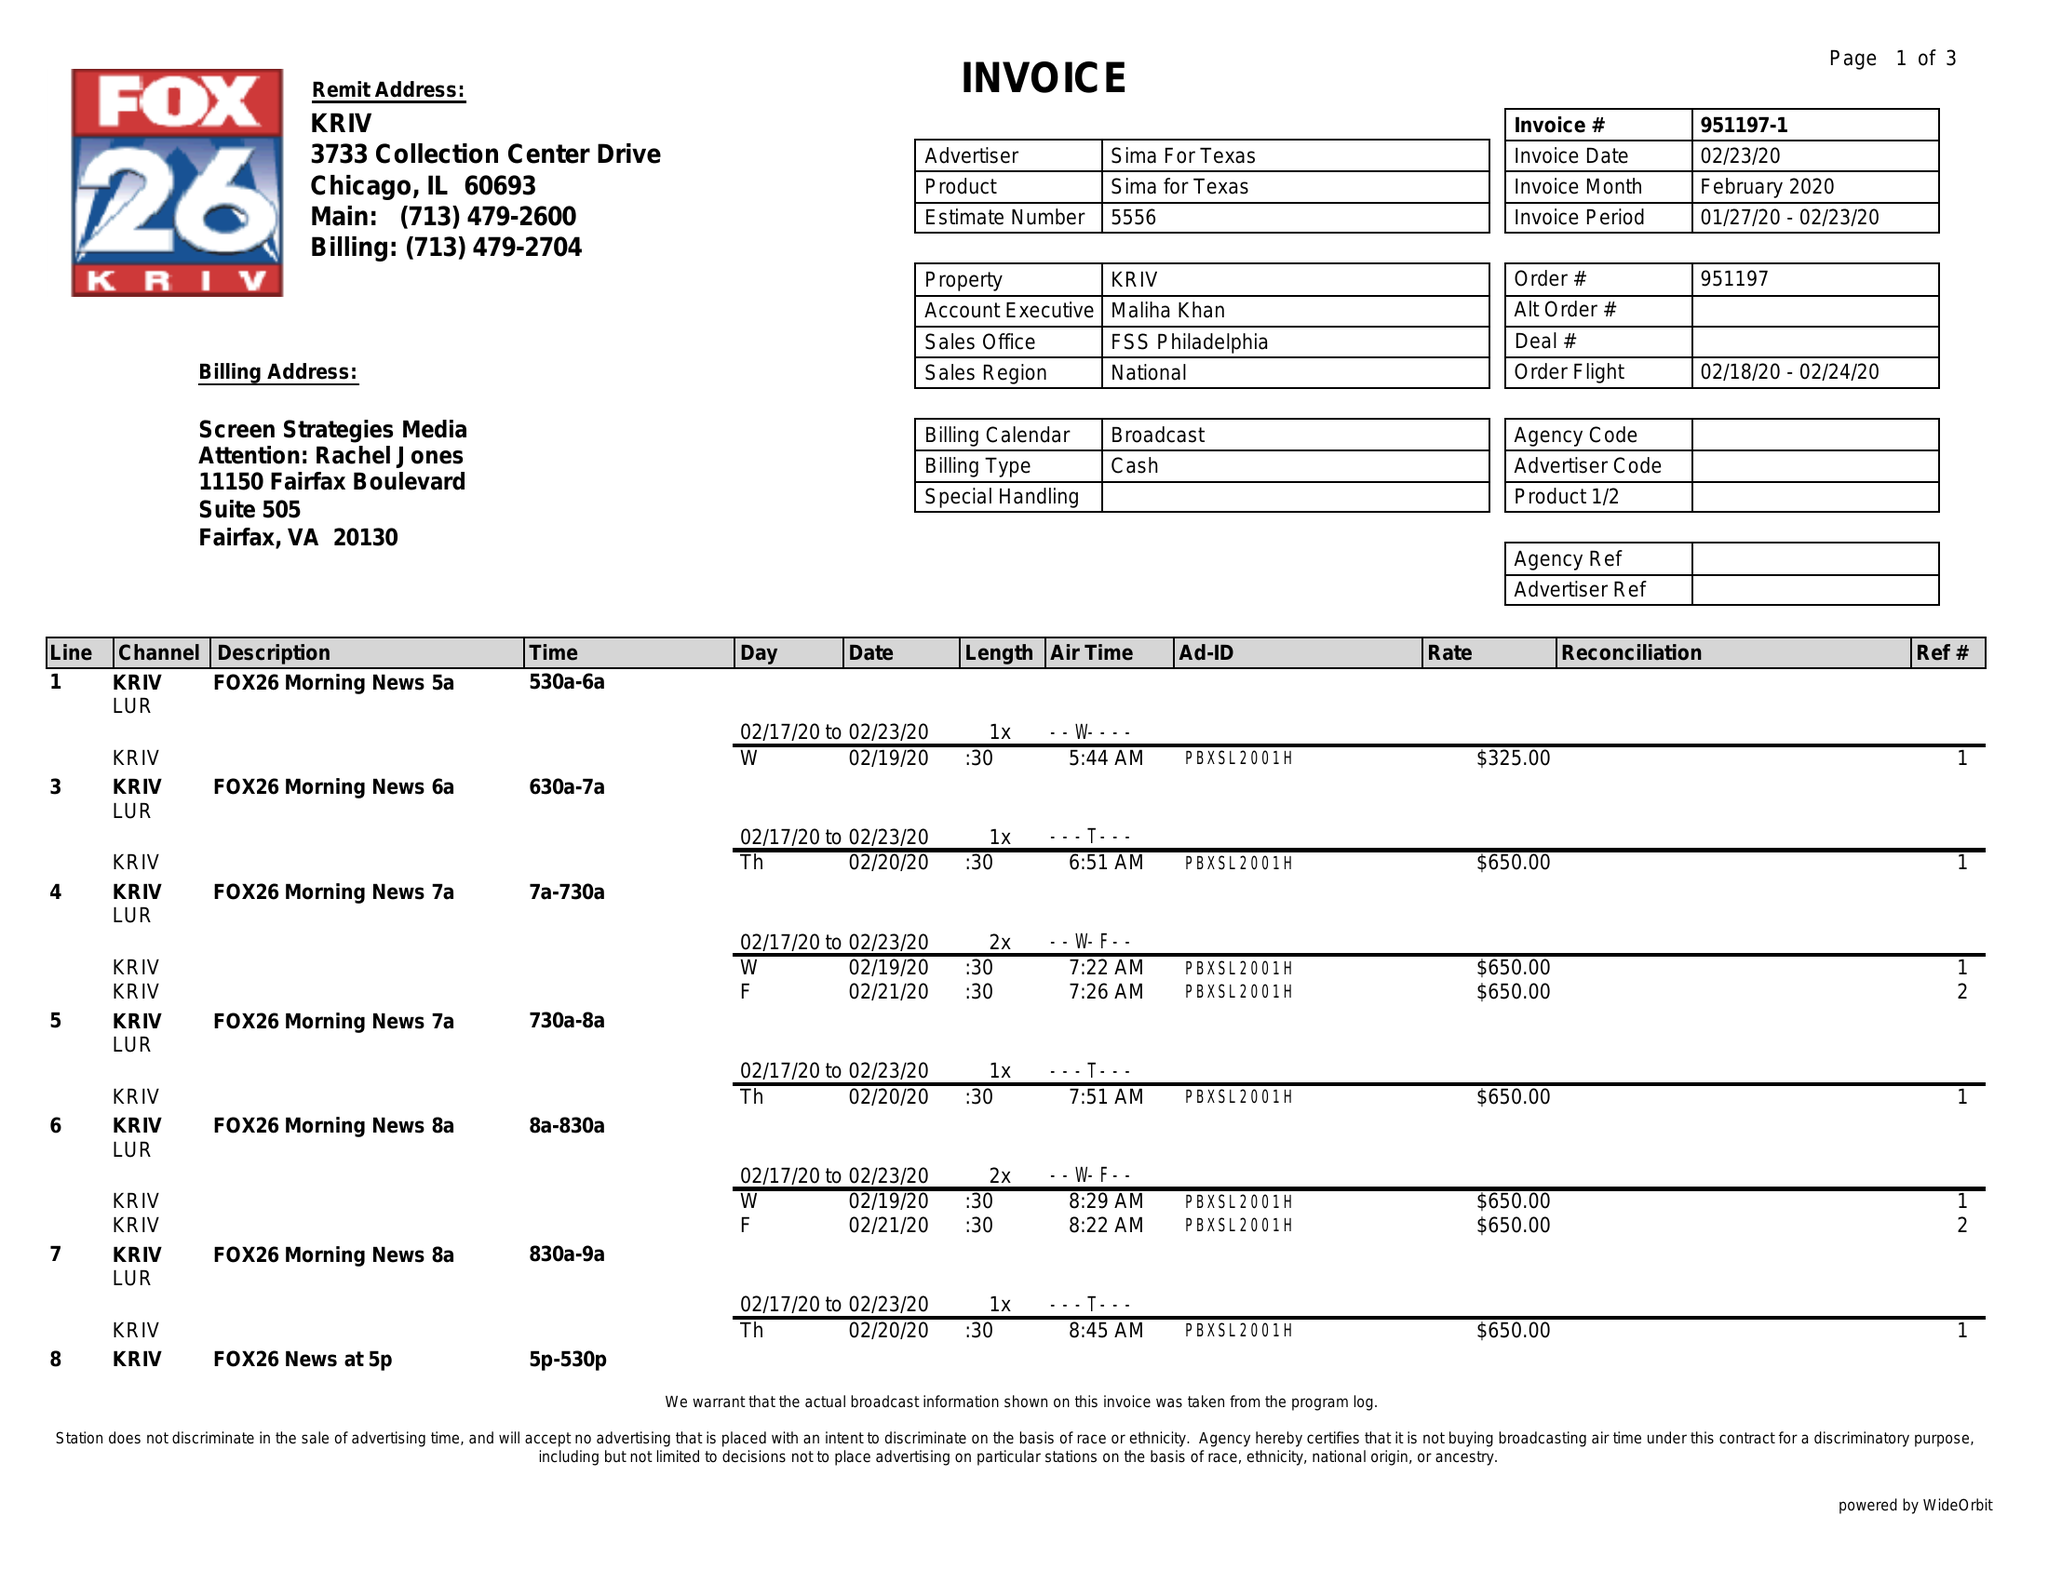What is the value for the gross_amount?
Answer the question using a single word or phrase. 10925.00 